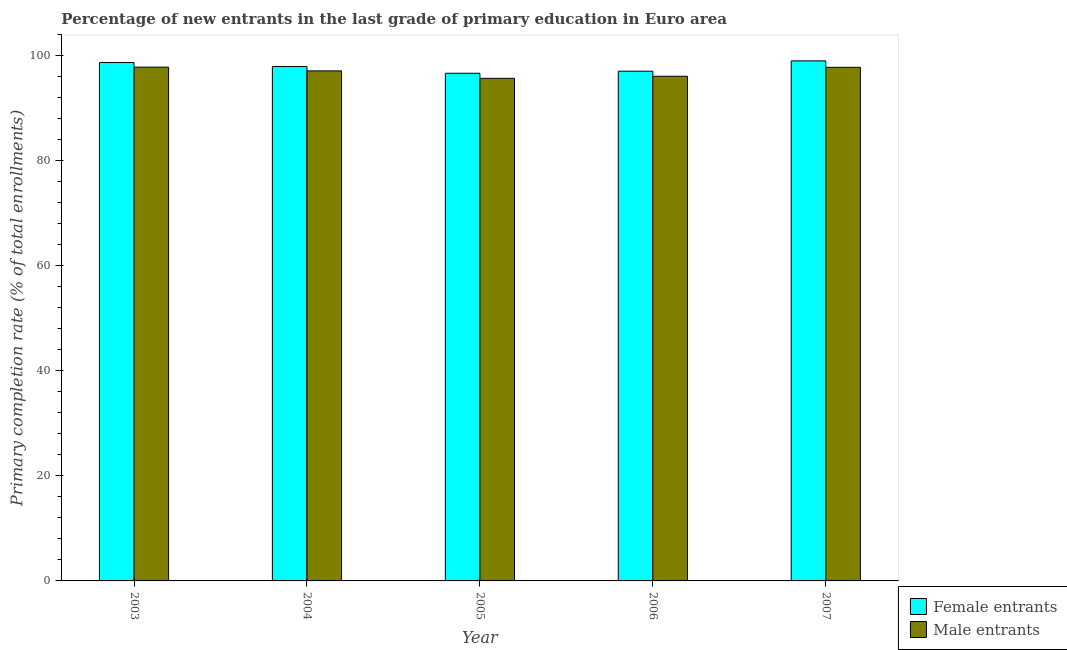Are the number of bars per tick equal to the number of legend labels?
Your answer should be compact. Yes. How many bars are there on the 4th tick from the left?
Offer a very short reply. 2. How many bars are there on the 2nd tick from the right?
Offer a very short reply. 2. What is the label of the 2nd group of bars from the left?
Your answer should be very brief. 2004. What is the primary completion rate of female entrants in 2005?
Keep it short and to the point. 96.71. Across all years, what is the maximum primary completion rate of male entrants?
Ensure brevity in your answer.  97.87. Across all years, what is the minimum primary completion rate of female entrants?
Your answer should be very brief. 96.71. In which year was the primary completion rate of male entrants maximum?
Offer a very short reply. 2003. What is the total primary completion rate of male entrants in the graph?
Your answer should be compact. 484.75. What is the difference between the primary completion rate of male entrants in 2003 and that in 2007?
Provide a succinct answer. 0.04. What is the difference between the primary completion rate of male entrants in 2006 and the primary completion rate of female entrants in 2003?
Your answer should be compact. -1.74. What is the average primary completion rate of female entrants per year?
Ensure brevity in your answer.  97.92. In how many years, is the primary completion rate of male entrants greater than 28 %?
Keep it short and to the point. 5. What is the ratio of the primary completion rate of female entrants in 2004 to that in 2006?
Your answer should be very brief. 1.01. What is the difference between the highest and the second highest primary completion rate of female entrants?
Offer a very short reply. 0.32. What is the difference between the highest and the lowest primary completion rate of female entrants?
Your answer should be very brief. 2.36. In how many years, is the primary completion rate of male entrants greater than the average primary completion rate of male entrants taken over all years?
Offer a terse response. 3. What does the 1st bar from the left in 2004 represents?
Provide a succinct answer. Female entrants. What does the 2nd bar from the right in 2006 represents?
Provide a succinct answer. Female entrants. Are all the bars in the graph horizontal?
Keep it short and to the point. No. Does the graph contain grids?
Keep it short and to the point. No. Where does the legend appear in the graph?
Give a very brief answer. Bottom right. How many legend labels are there?
Offer a terse response. 2. How are the legend labels stacked?
Make the answer very short. Vertical. What is the title of the graph?
Ensure brevity in your answer.  Percentage of new entrants in the last grade of primary education in Euro area. What is the label or title of the X-axis?
Give a very brief answer. Year. What is the label or title of the Y-axis?
Make the answer very short. Primary completion rate (% of total enrollments). What is the Primary completion rate (% of total enrollments) in Female entrants in 2003?
Your answer should be compact. 98.75. What is the Primary completion rate (% of total enrollments) in Male entrants in 2003?
Provide a succinct answer. 97.87. What is the Primary completion rate (% of total enrollments) in Female entrants in 2004?
Your response must be concise. 97.98. What is the Primary completion rate (% of total enrollments) of Male entrants in 2004?
Provide a short and direct response. 97.16. What is the Primary completion rate (% of total enrollments) of Female entrants in 2005?
Your response must be concise. 96.71. What is the Primary completion rate (% of total enrollments) of Male entrants in 2005?
Your answer should be very brief. 95.74. What is the Primary completion rate (% of total enrollments) in Female entrants in 2006?
Give a very brief answer. 97.1. What is the Primary completion rate (% of total enrollments) of Male entrants in 2006?
Keep it short and to the point. 96.14. What is the Primary completion rate (% of total enrollments) of Female entrants in 2007?
Keep it short and to the point. 99.07. What is the Primary completion rate (% of total enrollments) in Male entrants in 2007?
Your answer should be very brief. 97.84. Across all years, what is the maximum Primary completion rate (% of total enrollments) of Female entrants?
Give a very brief answer. 99.07. Across all years, what is the maximum Primary completion rate (% of total enrollments) of Male entrants?
Keep it short and to the point. 97.87. Across all years, what is the minimum Primary completion rate (% of total enrollments) of Female entrants?
Your answer should be very brief. 96.71. Across all years, what is the minimum Primary completion rate (% of total enrollments) in Male entrants?
Offer a very short reply. 95.74. What is the total Primary completion rate (% of total enrollments) in Female entrants in the graph?
Give a very brief answer. 489.61. What is the total Primary completion rate (% of total enrollments) in Male entrants in the graph?
Make the answer very short. 484.75. What is the difference between the Primary completion rate (% of total enrollments) of Female entrants in 2003 and that in 2004?
Give a very brief answer. 0.77. What is the difference between the Primary completion rate (% of total enrollments) of Male entrants in 2003 and that in 2004?
Keep it short and to the point. 0.71. What is the difference between the Primary completion rate (% of total enrollments) in Female entrants in 2003 and that in 2005?
Your answer should be compact. 2.04. What is the difference between the Primary completion rate (% of total enrollments) in Male entrants in 2003 and that in 2005?
Your answer should be very brief. 2.13. What is the difference between the Primary completion rate (% of total enrollments) of Female entrants in 2003 and that in 2006?
Your response must be concise. 1.65. What is the difference between the Primary completion rate (% of total enrollments) of Male entrants in 2003 and that in 2006?
Keep it short and to the point. 1.74. What is the difference between the Primary completion rate (% of total enrollments) of Female entrants in 2003 and that in 2007?
Keep it short and to the point. -0.32. What is the difference between the Primary completion rate (% of total enrollments) of Male entrants in 2003 and that in 2007?
Provide a succinct answer. 0.04. What is the difference between the Primary completion rate (% of total enrollments) in Female entrants in 2004 and that in 2005?
Provide a short and direct response. 1.28. What is the difference between the Primary completion rate (% of total enrollments) in Male entrants in 2004 and that in 2005?
Give a very brief answer. 1.42. What is the difference between the Primary completion rate (% of total enrollments) of Female entrants in 2004 and that in 2006?
Keep it short and to the point. 0.88. What is the difference between the Primary completion rate (% of total enrollments) in Male entrants in 2004 and that in 2006?
Provide a succinct answer. 1.02. What is the difference between the Primary completion rate (% of total enrollments) in Female entrants in 2004 and that in 2007?
Offer a terse response. -1.08. What is the difference between the Primary completion rate (% of total enrollments) of Male entrants in 2004 and that in 2007?
Keep it short and to the point. -0.68. What is the difference between the Primary completion rate (% of total enrollments) of Female entrants in 2005 and that in 2006?
Ensure brevity in your answer.  -0.39. What is the difference between the Primary completion rate (% of total enrollments) of Male entrants in 2005 and that in 2006?
Your answer should be very brief. -0.4. What is the difference between the Primary completion rate (% of total enrollments) of Female entrants in 2005 and that in 2007?
Ensure brevity in your answer.  -2.36. What is the difference between the Primary completion rate (% of total enrollments) of Male entrants in 2005 and that in 2007?
Offer a terse response. -2.1. What is the difference between the Primary completion rate (% of total enrollments) in Female entrants in 2006 and that in 2007?
Your response must be concise. -1.96. What is the difference between the Primary completion rate (% of total enrollments) in Male entrants in 2006 and that in 2007?
Your answer should be very brief. -1.7. What is the difference between the Primary completion rate (% of total enrollments) in Female entrants in 2003 and the Primary completion rate (% of total enrollments) in Male entrants in 2004?
Ensure brevity in your answer.  1.59. What is the difference between the Primary completion rate (% of total enrollments) of Female entrants in 2003 and the Primary completion rate (% of total enrollments) of Male entrants in 2005?
Offer a very short reply. 3.01. What is the difference between the Primary completion rate (% of total enrollments) of Female entrants in 2003 and the Primary completion rate (% of total enrollments) of Male entrants in 2006?
Offer a very short reply. 2.61. What is the difference between the Primary completion rate (% of total enrollments) in Female entrants in 2003 and the Primary completion rate (% of total enrollments) in Male entrants in 2007?
Offer a terse response. 0.91. What is the difference between the Primary completion rate (% of total enrollments) in Female entrants in 2004 and the Primary completion rate (% of total enrollments) in Male entrants in 2005?
Offer a very short reply. 2.24. What is the difference between the Primary completion rate (% of total enrollments) of Female entrants in 2004 and the Primary completion rate (% of total enrollments) of Male entrants in 2006?
Provide a succinct answer. 1.85. What is the difference between the Primary completion rate (% of total enrollments) of Female entrants in 2004 and the Primary completion rate (% of total enrollments) of Male entrants in 2007?
Make the answer very short. 0.15. What is the difference between the Primary completion rate (% of total enrollments) of Female entrants in 2005 and the Primary completion rate (% of total enrollments) of Male entrants in 2006?
Your answer should be compact. 0.57. What is the difference between the Primary completion rate (% of total enrollments) in Female entrants in 2005 and the Primary completion rate (% of total enrollments) in Male entrants in 2007?
Your answer should be very brief. -1.13. What is the difference between the Primary completion rate (% of total enrollments) of Female entrants in 2006 and the Primary completion rate (% of total enrollments) of Male entrants in 2007?
Provide a succinct answer. -0.74. What is the average Primary completion rate (% of total enrollments) of Female entrants per year?
Ensure brevity in your answer.  97.92. What is the average Primary completion rate (% of total enrollments) in Male entrants per year?
Ensure brevity in your answer.  96.95. In the year 2003, what is the difference between the Primary completion rate (% of total enrollments) in Female entrants and Primary completion rate (% of total enrollments) in Male entrants?
Provide a succinct answer. 0.88. In the year 2004, what is the difference between the Primary completion rate (% of total enrollments) in Female entrants and Primary completion rate (% of total enrollments) in Male entrants?
Offer a very short reply. 0.82. In the year 2005, what is the difference between the Primary completion rate (% of total enrollments) of Female entrants and Primary completion rate (% of total enrollments) of Male entrants?
Make the answer very short. 0.97. In the year 2006, what is the difference between the Primary completion rate (% of total enrollments) of Female entrants and Primary completion rate (% of total enrollments) of Male entrants?
Your answer should be compact. 0.96. In the year 2007, what is the difference between the Primary completion rate (% of total enrollments) in Female entrants and Primary completion rate (% of total enrollments) in Male entrants?
Give a very brief answer. 1.23. What is the ratio of the Primary completion rate (% of total enrollments) in Female entrants in 2003 to that in 2004?
Your response must be concise. 1.01. What is the ratio of the Primary completion rate (% of total enrollments) in Male entrants in 2003 to that in 2004?
Your answer should be compact. 1.01. What is the ratio of the Primary completion rate (% of total enrollments) in Female entrants in 2003 to that in 2005?
Offer a very short reply. 1.02. What is the ratio of the Primary completion rate (% of total enrollments) of Male entrants in 2003 to that in 2005?
Make the answer very short. 1.02. What is the ratio of the Primary completion rate (% of total enrollments) in Female entrants in 2003 to that in 2006?
Offer a very short reply. 1.02. What is the ratio of the Primary completion rate (% of total enrollments) of Male entrants in 2003 to that in 2006?
Keep it short and to the point. 1.02. What is the ratio of the Primary completion rate (% of total enrollments) in Male entrants in 2003 to that in 2007?
Provide a short and direct response. 1. What is the ratio of the Primary completion rate (% of total enrollments) of Female entrants in 2004 to that in 2005?
Give a very brief answer. 1.01. What is the ratio of the Primary completion rate (% of total enrollments) in Male entrants in 2004 to that in 2005?
Make the answer very short. 1.01. What is the ratio of the Primary completion rate (% of total enrollments) in Female entrants in 2004 to that in 2006?
Make the answer very short. 1.01. What is the ratio of the Primary completion rate (% of total enrollments) of Male entrants in 2004 to that in 2006?
Your answer should be very brief. 1.01. What is the ratio of the Primary completion rate (% of total enrollments) of Male entrants in 2004 to that in 2007?
Make the answer very short. 0.99. What is the ratio of the Primary completion rate (% of total enrollments) of Female entrants in 2005 to that in 2007?
Give a very brief answer. 0.98. What is the ratio of the Primary completion rate (% of total enrollments) of Male entrants in 2005 to that in 2007?
Your response must be concise. 0.98. What is the ratio of the Primary completion rate (% of total enrollments) in Female entrants in 2006 to that in 2007?
Make the answer very short. 0.98. What is the ratio of the Primary completion rate (% of total enrollments) of Male entrants in 2006 to that in 2007?
Give a very brief answer. 0.98. What is the difference between the highest and the second highest Primary completion rate (% of total enrollments) in Female entrants?
Keep it short and to the point. 0.32. What is the difference between the highest and the second highest Primary completion rate (% of total enrollments) of Male entrants?
Make the answer very short. 0.04. What is the difference between the highest and the lowest Primary completion rate (% of total enrollments) of Female entrants?
Offer a terse response. 2.36. What is the difference between the highest and the lowest Primary completion rate (% of total enrollments) of Male entrants?
Provide a succinct answer. 2.13. 